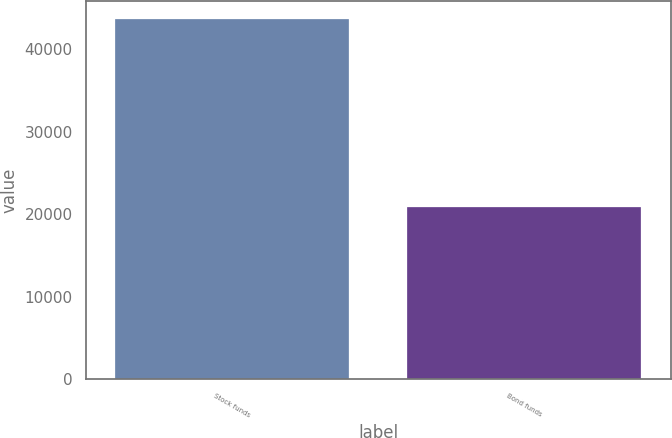Convert chart. <chart><loc_0><loc_0><loc_500><loc_500><bar_chart><fcel>Stock funds<fcel>Bond funds<nl><fcel>43595<fcel>20894<nl></chart> 